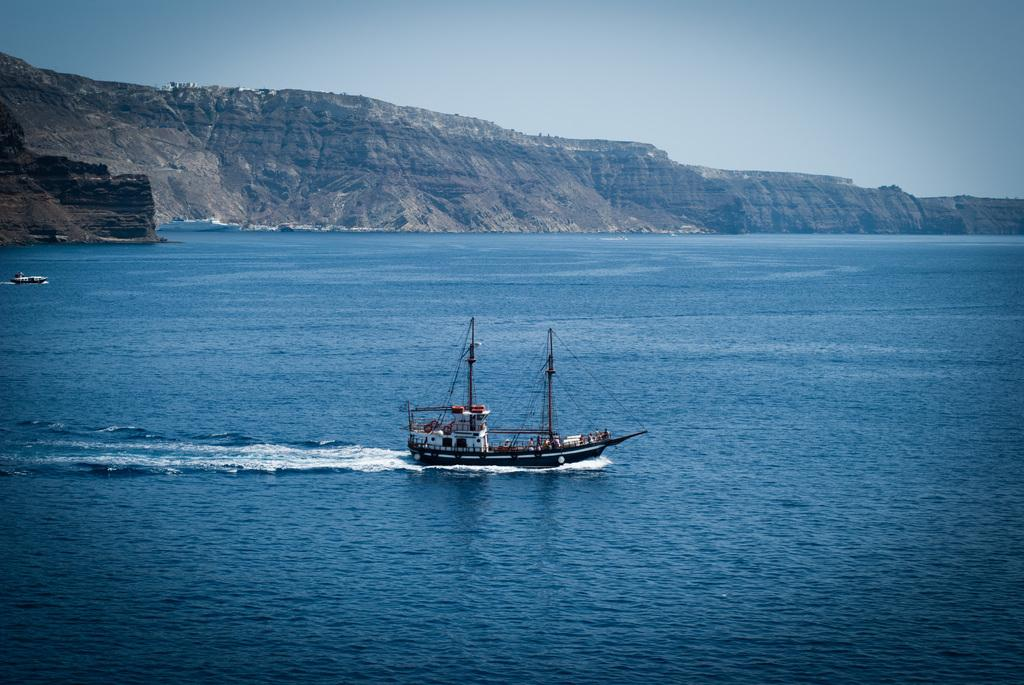What is located in the water in the image? There is a boat in the water in the image. What can be seen in the background of the image? There are hills in the background of the image. What is visible at the top of the image? The sky is visible at the top of the image. What type of coat is the boat wearing in the image? Boats do not wear coats, as they are inanimate objects. 